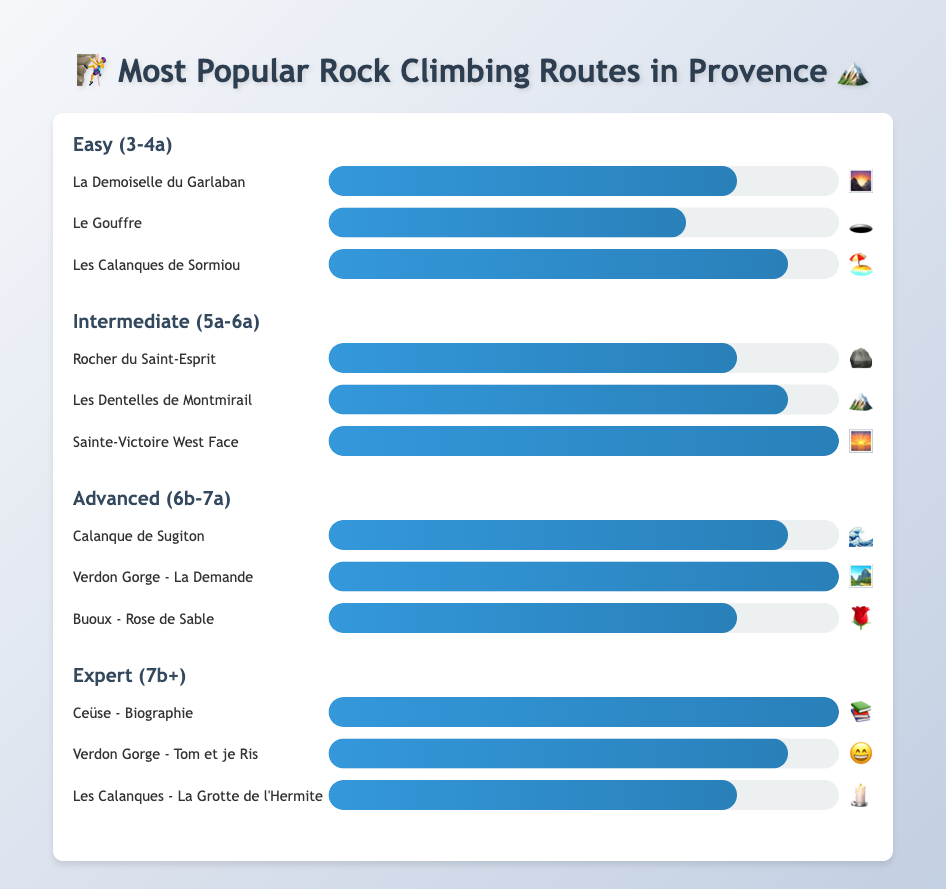Which easy route has the highest popularity? The "Les Calanques de Sormiou" route in the Easy category has the highest popularity, as indicated by the longest bar reaching 90%.
Answer: Les Calanques de Sormiou Which route has the highest popularity in the Intermediate category? The "Sainte-Victoire West Face" route has the highest popularity in the Intermediate category, indicated by its bar's full length of 100%.
Answer: Sainte-Victoire West Face What is the total popularity score of all routes in the Expert category? Adding up the popularity scores for the Expert routes: Ceüse - Biographie (10) + Verdon Gorge - Tom et je Ris (9) + Les Calanques - La Grotte de l'Hermite (8) results in a total score of 27.
Answer: 27 Which route in the Advanced category has a lower popularity than "Calanque de Sugiton"? The "Buoux - Rose de Sable" route has a lower popularity (80%) compared to "Calanque de Sugiton" which has a popularity of 90%.
Answer: Buoux - Rose de Sable How does the popularity of "Rocher du Saint-Esprit" compare with "Le Gouffre"? "Rocher du Saint-Esprit" has a popularity of 80%, which is higher than "Le Gouffre" at 70%.
Answer: Rocher du Saint-Esprit is more popular than Le Gouffre Which category has the route with the highest overall popularity? The categories Intermediate, Advanced, and Expert all have a route with a 100% popularity score - "Sainte-Victoire West Face," "Verdon Gorge - La Demande," and "Ceüse - Biographie," respectively.
Answer: Intermediate, Advanced, and Expert Between "Verdon Gorge - Tom et je Ris" and "Verdon Gorge - La Demande," which has higher popularity? "Verdon Gorge - La Demande" from the Advanced category has higher popularity (100%) compared to "Verdon Gorge - Tom et je Ris" from the Expert category (90%).
Answer: Verdon Gorge - La Demande What is the average popularity of the routes in the Easy category? The popularity scores for the Easy routes are 8, 7, and 9. Adding these gives 24, and dividing by 3 routes results in an average of 8.
Answer: 8 What is the emoji associated with the route "Les Calanques - La Grotte de l'Hermite"? The emoji associated with "Les Calanques - La Grotte de l'Hermite" is a candle.
Answer: 🕯️ 